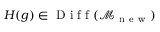<formula> <loc_0><loc_0><loc_500><loc_500>H ( g ) \in D i f f ( \mathcal { M } _ { n e w } )</formula> 